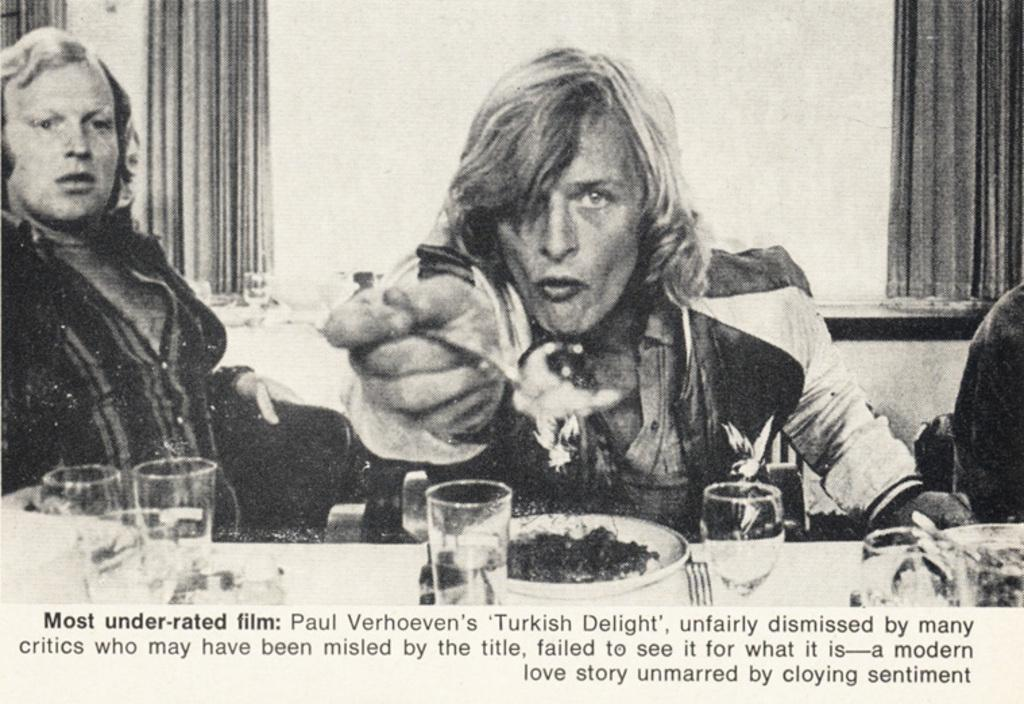What is the main subject of the image? The main subject of the image is a picture of a newspaper. What types of objects are depicted in the images within the newspaper? The images within the newspaper contain glasses, plates, and people. What type of crib is visible in the image? There is no crib present in the image; it features a picture of a newspaper with images of glasses, plates, and people. How does the temper of the people in the images affect the overall tone of the newspaper? The provided facts do not mention the temper of the people in the images, so it is impossible to determine how their temper might affect the overall tone of the newspaper. 